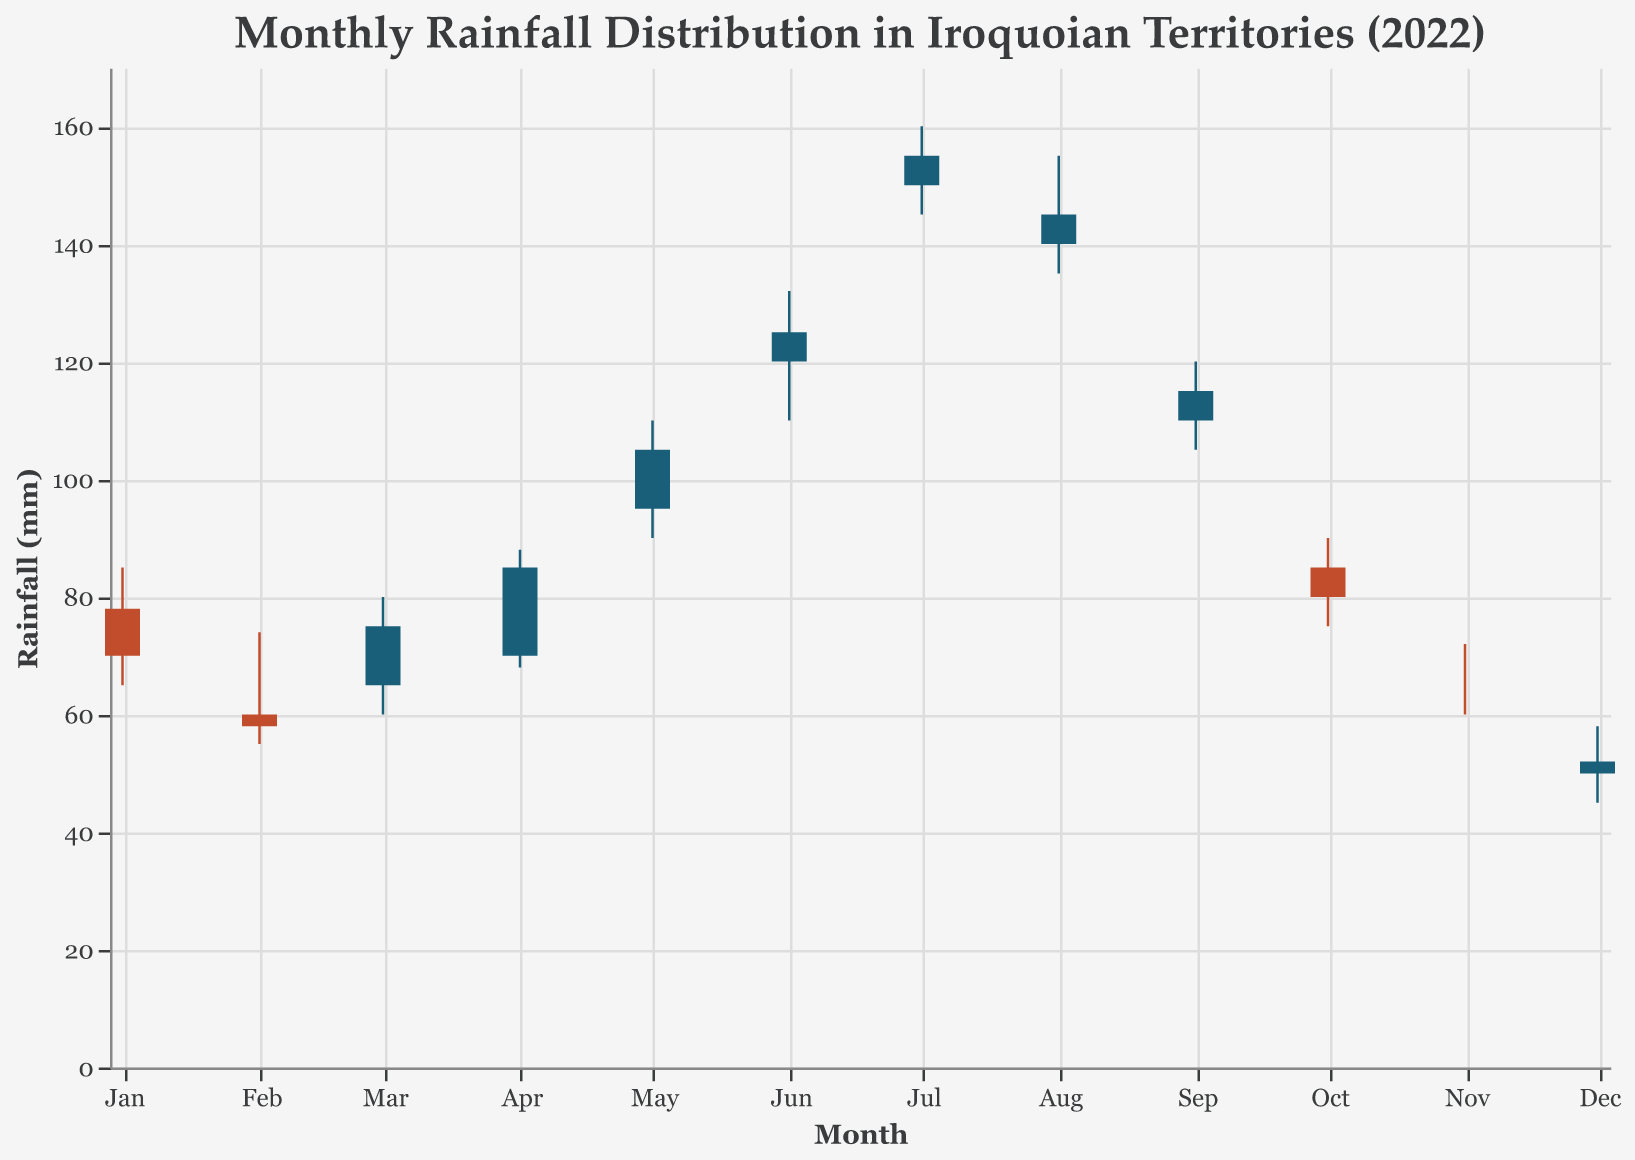What is the title of the plot? The title of the plot is usually found at the top of the figure. It states that the plot is about the monthly rainfall distribution in Iroquoian territories for the year 2022.
Answer: Monthly Rainfall Distribution in Iroquoian Territories (2022) In which month did the rainfall have the highest maximum value? The maximum value of rainfall for each month is represented by the highest point of the candlestick (High). July has the highest maximum value at 160 mm.
Answer: July Which months had a closing value higher than the opening value? The condition where the closing value is higher than the opening value is when the bar is colored in a specific color. According to the provided encoding, months that meet this condition are March, April, May, June, July, and September.
Answer: March, April, May, June, July, September What months have the least and most consistent rainfall distributions? Consistency can be interpreted by the range between low (Low) and high (High) values. January has a high variability, whereas November shows lesser variability between low and high values indicating that January has the most variability and November the least.
Answer: January (most), November (least) How did the rainfall distribution change between June and July? Look at the position and size of the candlestick bars for June and July. The open value increased from 120 mm in June to 150 mm in July; the high increased from 132 mm to 160 mm; the low increased from 110 mm to 145 mm, and the close increased from 125 mm to 155 mm.
Answer: All values increased Which month had the smallest range of rainfall values (High - Low)? Calculate the range (High - Low) for each month and identify the smallest. November has the smallest range, with a difference of 12 mm.
Answer: November What are the months where the closing value is lower than the opening value? The candlestick color indicates months where the closing value is lower than the opening value. These months are January, February, August, October, and December.
Answer: January, February, August, October, December How does the rainfall in September compare to August in terms of variability? Compare the high, low, and differences (ranges) for August and September. August has a high of 155 mm and low of 135 mm with a range of 20 mm, while September has a high of 120 mm and low of 105 mm with a range of 15 mm.
Answer: September is less variable What was the overall trend of rainfall from January to December? Observing the candlestick positions from January to December, there is an initial decline in January and February, a gradual increase from March to July, and a decline from August back to December.
Answer: Initial decrease, then increase to July, then decrease 